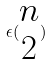<formula> <loc_0><loc_0><loc_500><loc_500>\epsilon ( \begin{matrix} n \\ 2 \end{matrix} )</formula> 